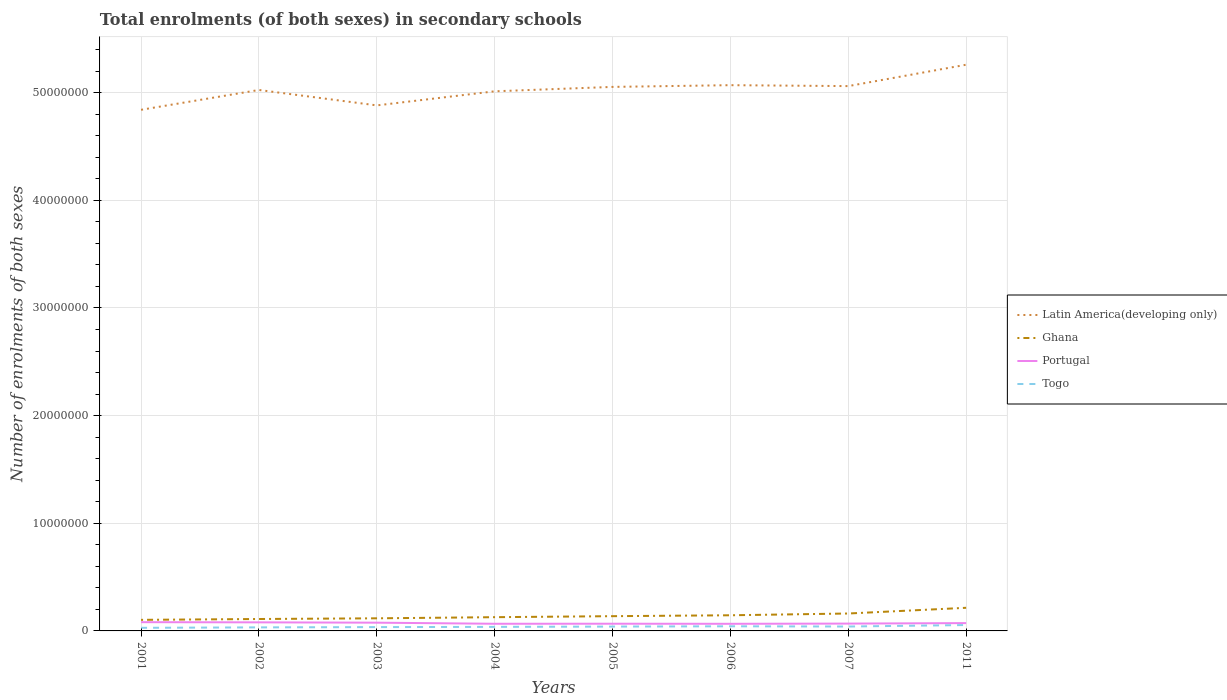How many different coloured lines are there?
Offer a terse response. 4. Across all years, what is the maximum number of enrolments in secondary schools in Latin America(developing only)?
Your answer should be compact. 4.84e+07. In which year was the number of enrolments in secondary schools in Togo maximum?
Your answer should be compact. 2001. What is the total number of enrolments in secondary schools in Portugal in the graph?
Provide a short and direct response. 3.09e+04. What is the difference between the highest and the second highest number of enrolments in secondary schools in Ghana?
Keep it short and to the point. 1.12e+06. Is the number of enrolments in secondary schools in Portugal strictly greater than the number of enrolments in secondary schools in Ghana over the years?
Provide a short and direct response. Yes. How many lines are there?
Offer a terse response. 4. How many years are there in the graph?
Ensure brevity in your answer.  8. Are the values on the major ticks of Y-axis written in scientific E-notation?
Offer a very short reply. No. Does the graph contain any zero values?
Provide a succinct answer. No. How are the legend labels stacked?
Ensure brevity in your answer.  Vertical. What is the title of the graph?
Make the answer very short. Total enrolments (of both sexes) in secondary schools. What is the label or title of the X-axis?
Offer a terse response. Years. What is the label or title of the Y-axis?
Provide a succinct answer. Number of enrolments of both sexes. What is the Number of enrolments of both sexes in Latin America(developing only) in 2001?
Provide a short and direct response. 4.84e+07. What is the Number of enrolments of both sexes in Ghana in 2001?
Provide a short and direct response. 1.03e+06. What is the Number of enrolments of both sexes of Portugal in 2001?
Your answer should be very brief. 8.13e+05. What is the Number of enrolments of both sexes of Togo in 2001?
Offer a very short reply. 2.88e+05. What is the Number of enrolments of both sexes of Latin America(developing only) in 2002?
Ensure brevity in your answer.  5.03e+07. What is the Number of enrolments of both sexes of Ghana in 2002?
Provide a succinct answer. 1.11e+06. What is the Number of enrolments of both sexes of Portugal in 2002?
Give a very brief answer. 7.97e+05. What is the Number of enrolments of both sexes in Togo in 2002?
Make the answer very short. 3.29e+05. What is the Number of enrolments of both sexes of Latin America(developing only) in 2003?
Offer a terse response. 4.88e+07. What is the Number of enrolments of both sexes of Ghana in 2003?
Make the answer very short. 1.17e+06. What is the Number of enrolments of both sexes of Portugal in 2003?
Keep it short and to the point. 7.66e+05. What is the Number of enrolments of both sexes in Togo in 2003?
Provide a short and direct response. 3.55e+05. What is the Number of enrolments of both sexes in Latin America(developing only) in 2004?
Keep it short and to the point. 5.01e+07. What is the Number of enrolments of both sexes of Ghana in 2004?
Keep it short and to the point. 1.28e+06. What is the Number of enrolments of both sexes in Portugal in 2004?
Your answer should be very brief. 6.65e+05. What is the Number of enrolments of both sexes of Togo in 2004?
Provide a short and direct response. 3.75e+05. What is the Number of enrolments of both sexes in Latin America(developing only) in 2005?
Your answer should be compact. 5.05e+07. What is the Number of enrolments of both sexes of Ghana in 2005?
Provide a short and direct response. 1.37e+06. What is the Number of enrolments of both sexes of Portugal in 2005?
Your answer should be very brief. 6.70e+05. What is the Number of enrolments of both sexes in Togo in 2005?
Ensure brevity in your answer.  4.04e+05. What is the Number of enrolments of both sexes in Latin America(developing only) in 2006?
Keep it short and to the point. 5.07e+07. What is the Number of enrolments of both sexes in Ghana in 2006?
Make the answer very short. 1.45e+06. What is the Number of enrolments of both sexes in Portugal in 2006?
Give a very brief answer. 6.62e+05. What is the Number of enrolments of both sexes in Togo in 2006?
Keep it short and to the point. 4.30e+05. What is the Number of enrolments of both sexes of Latin America(developing only) in 2007?
Your answer should be very brief. 5.06e+07. What is the Number of enrolments of both sexes in Ghana in 2007?
Make the answer very short. 1.62e+06. What is the Number of enrolments of both sexes of Portugal in 2007?
Provide a short and direct response. 6.80e+05. What is the Number of enrolments of both sexes in Togo in 2007?
Your response must be concise. 4.09e+05. What is the Number of enrolments of both sexes of Latin America(developing only) in 2011?
Keep it short and to the point. 5.26e+07. What is the Number of enrolments of both sexes in Ghana in 2011?
Make the answer very short. 2.15e+06. What is the Number of enrolments of both sexes of Portugal in 2011?
Keep it short and to the point. 7.26e+05. What is the Number of enrolments of both sexes of Togo in 2011?
Ensure brevity in your answer.  5.46e+05. Across all years, what is the maximum Number of enrolments of both sexes of Latin America(developing only)?
Your answer should be compact. 5.26e+07. Across all years, what is the maximum Number of enrolments of both sexes of Ghana?
Provide a succinct answer. 2.15e+06. Across all years, what is the maximum Number of enrolments of both sexes of Portugal?
Make the answer very short. 8.13e+05. Across all years, what is the maximum Number of enrolments of both sexes of Togo?
Provide a short and direct response. 5.46e+05. Across all years, what is the minimum Number of enrolments of both sexes in Latin America(developing only)?
Make the answer very short. 4.84e+07. Across all years, what is the minimum Number of enrolments of both sexes in Ghana?
Give a very brief answer. 1.03e+06. Across all years, what is the minimum Number of enrolments of both sexes of Portugal?
Give a very brief answer. 6.62e+05. Across all years, what is the minimum Number of enrolments of both sexes of Togo?
Your answer should be compact. 2.88e+05. What is the total Number of enrolments of both sexes in Latin America(developing only) in the graph?
Provide a short and direct response. 4.02e+08. What is the total Number of enrolments of both sexes of Ghana in the graph?
Your answer should be very brief. 1.12e+07. What is the total Number of enrolments of both sexes of Portugal in the graph?
Keep it short and to the point. 5.78e+06. What is the total Number of enrolments of both sexes of Togo in the graph?
Make the answer very short. 3.14e+06. What is the difference between the Number of enrolments of both sexes in Latin America(developing only) in 2001 and that in 2002?
Give a very brief answer. -1.84e+06. What is the difference between the Number of enrolments of both sexes of Ghana in 2001 and that in 2002?
Provide a succinct answer. -7.80e+04. What is the difference between the Number of enrolments of both sexes of Portugal in 2001 and that in 2002?
Provide a succinct answer. 1.61e+04. What is the difference between the Number of enrolments of both sexes of Togo in 2001 and that in 2002?
Provide a short and direct response. -4.10e+04. What is the difference between the Number of enrolments of both sexes of Latin America(developing only) in 2001 and that in 2003?
Your answer should be very brief. -4.09e+05. What is the difference between the Number of enrolments of both sexes in Ghana in 2001 and that in 2003?
Provide a succinct answer. -1.42e+05. What is the difference between the Number of enrolments of both sexes in Portugal in 2001 and that in 2003?
Your answer should be compact. 4.70e+04. What is the difference between the Number of enrolments of both sexes in Togo in 2001 and that in 2003?
Your answer should be compact. -6.66e+04. What is the difference between the Number of enrolments of both sexes in Latin America(developing only) in 2001 and that in 2004?
Offer a very short reply. -1.72e+06. What is the difference between the Number of enrolments of both sexes in Ghana in 2001 and that in 2004?
Your response must be concise. -2.47e+05. What is the difference between the Number of enrolments of both sexes in Portugal in 2001 and that in 2004?
Give a very brief answer. 1.48e+05. What is the difference between the Number of enrolments of both sexes of Togo in 2001 and that in 2004?
Make the answer very short. -8.70e+04. What is the difference between the Number of enrolments of both sexes in Latin America(developing only) in 2001 and that in 2005?
Ensure brevity in your answer.  -2.13e+06. What is the difference between the Number of enrolments of both sexes of Ghana in 2001 and that in 2005?
Give a very brief answer. -3.41e+05. What is the difference between the Number of enrolments of both sexes in Portugal in 2001 and that in 2005?
Provide a succinct answer. 1.44e+05. What is the difference between the Number of enrolments of both sexes of Togo in 2001 and that in 2005?
Offer a very short reply. -1.16e+05. What is the difference between the Number of enrolments of both sexes of Latin America(developing only) in 2001 and that in 2006?
Provide a succinct answer. -2.29e+06. What is the difference between the Number of enrolments of both sexes of Ghana in 2001 and that in 2006?
Make the answer very short. -4.25e+05. What is the difference between the Number of enrolments of both sexes of Portugal in 2001 and that in 2006?
Your response must be concise. 1.51e+05. What is the difference between the Number of enrolments of both sexes of Togo in 2001 and that in 2006?
Offer a very short reply. -1.42e+05. What is the difference between the Number of enrolments of both sexes of Latin America(developing only) in 2001 and that in 2007?
Provide a short and direct response. -2.20e+06. What is the difference between the Number of enrolments of both sexes of Ghana in 2001 and that in 2007?
Offer a terse response. -5.89e+05. What is the difference between the Number of enrolments of both sexes of Portugal in 2001 and that in 2007?
Make the answer very short. 1.33e+05. What is the difference between the Number of enrolments of both sexes of Togo in 2001 and that in 2007?
Your answer should be compact. -1.21e+05. What is the difference between the Number of enrolments of both sexes in Latin America(developing only) in 2001 and that in 2011?
Provide a short and direct response. -4.19e+06. What is the difference between the Number of enrolments of both sexes in Ghana in 2001 and that in 2011?
Offer a very short reply. -1.12e+06. What is the difference between the Number of enrolments of both sexes of Portugal in 2001 and that in 2011?
Offer a very short reply. 8.74e+04. What is the difference between the Number of enrolments of both sexes of Togo in 2001 and that in 2011?
Ensure brevity in your answer.  -2.58e+05. What is the difference between the Number of enrolments of both sexes in Latin America(developing only) in 2002 and that in 2003?
Offer a terse response. 1.43e+06. What is the difference between the Number of enrolments of both sexes in Ghana in 2002 and that in 2003?
Give a very brief answer. -6.35e+04. What is the difference between the Number of enrolments of both sexes of Portugal in 2002 and that in 2003?
Your response must be concise. 3.09e+04. What is the difference between the Number of enrolments of both sexes of Togo in 2002 and that in 2003?
Your answer should be very brief. -2.57e+04. What is the difference between the Number of enrolments of both sexes in Latin America(developing only) in 2002 and that in 2004?
Your answer should be very brief. 1.23e+05. What is the difference between the Number of enrolments of both sexes of Ghana in 2002 and that in 2004?
Offer a terse response. -1.69e+05. What is the difference between the Number of enrolments of both sexes of Portugal in 2002 and that in 2004?
Provide a short and direct response. 1.32e+05. What is the difference between the Number of enrolments of both sexes in Togo in 2002 and that in 2004?
Make the answer very short. -4.61e+04. What is the difference between the Number of enrolments of both sexes in Latin America(developing only) in 2002 and that in 2005?
Make the answer very short. -2.86e+05. What is the difference between the Number of enrolments of both sexes in Ghana in 2002 and that in 2005?
Give a very brief answer. -2.63e+05. What is the difference between the Number of enrolments of both sexes in Portugal in 2002 and that in 2005?
Ensure brevity in your answer.  1.28e+05. What is the difference between the Number of enrolments of both sexes in Togo in 2002 and that in 2005?
Your response must be concise. -7.52e+04. What is the difference between the Number of enrolments of both sexes of Latin America(developing only) in 2002 and that in 2006?
Your answer should be very brief. -4.47e+05. What is the difference between the Number of enrolments of both sexes of Ghana in 2002 and that in 2006?
Keep it short and to the point. -3.47e+05. What is the difference between the Number of enrolments of both sexes of Portugal in 2002 and that in 2006?
Provide a succinct answer. 1.35e+05. What is the difference between the Number of enrolments of both sexes of Togo in 2002 and that in 2006?
Offer a terse response. -1.01e+05. What is the difference between the Number of enrolments of both sexes in Latin America(developing only) in 2002 and that in 2007?
Make the answer very short. -3.61e+05. What is the difference between the Number of enrolments of both sexes in Ghana in 2002 and that in 2007?
Make the answer very short. -5.11e+05. What is the difference between the Number of enrolments of both sexes of Portugal in 2002 and that in 2007?
Keep it short and to the point. 1.17e+05. What is the difference between the Number of enrolments of both sexes of Togo in 2002 and that in 2007?
Provide a short and direct response. -7.97e+04. What is the difference between the Number of enrolments of both sexes in Latin America(developing only) in 2002 and that in 2011?
Provide a short and direct response. -2.35e+06. What is the difference between the Number of enrolments of both sexes of Ghana in 2002 and that in 2011?
Make the answer very short. -1.04e+06. What is the difference between the Number of enrolments of both sexes of Portugal in 2002 and that in 2011?
Keep it short and to the point. 7.13e+04. What is the difference between the Number of enrolments of both sexes in Togo in 2002 and that in 2011?
Keep it short and to the point. -2.17e+05. What is the difference between the Number of enrolments of both sexes of Latin America(developing only) in 2003 and that in 2004?
Provide a short and direct response. -1.31e+06. What is the difference between the Number of enrolments of both sexes in Ghana in 2003 and that in 2004?
Make the answer very short. -1.06e+05. What is the difference between the Number of enrolments of both sexes in Portugal in 2003 and that in 2004?
Your response must be concise. 1.01e+05. What is the difference between the Number of enrolments of both sexes in Togo in 2003 and that in 2004?
Make the answer very short. -2.04e+04. What is the difference between the Number of enrolments of both sexes of Latin America(developing only) in 2003 and that in 2005?
Your answer should be very brief. -1.72e+06. What is the difference between the Number of enrolments of both sexes of Ghana in 2003 and that in 2005?
Your response must be concise. -1.99e+05. What is the difference between the Number of enrolments of both sexes in Portugal in 2003 and that in 2005?
Make the answer very short. 9.66e+04. What is the difference between the Number of enrolments of both sexes of Togo in 2003 and that in 2005?
Provide a short and direct response. -4.95e+04. What is the difference between the Number of enrolments of both sexes of Latin America(developing only) in 2003 and that in 2006?
Give a very brief answer. -1.88e+06. What is the difference between the Number of enrolments of both sexes of Ghana in 2003 and that in 2006?
Make the answer very short. -2.83e+05. What is the difference between the Number of enrolments of both sexes of Portugal in 2003 and that in 2006?
Make the answer very short. 1.04e+05. What is the difference between the Number of enrolments of both sexes in Togo in 2003 and that in 2006?
Provide a short and direct response. -7.51e+04. What is the difference between the Number of enrolments of both sexes in Latin America(developing only) in 2003 and that in 2007?
Give a very brief answer. -1.79e+06. What is the difference between the Number of enrolments of both sexes of Ghana in 2003 and that in 2007?
Give a very brief answer. -4.47e+05. What is the difference between the Number of enrolments of both sexes in Portugal in 2003 and that in 2007?
Give a very brief answer. 8.58e+04. What is the difference between the Number of enrolments of both sexes of Togo in 2003 and that in 2007?
Offer a terse response. -5.40e+04. What is the difference between the Number of enrolments of both sexes of Latin America(developing only) in 2003 and that in 2011?
Provide a short and direct response. -3.78e+06. What is the difference between the Number of enrolments of both sexes in Ghana in 2003 and that in 2011?
Your response must be concise. -9.78e+05. What is the difference between the Number of enrolments of both sexes of Portugal in 2003 and that in 2011?
Make the answer very short. 4.04e+04. What is the difference between the Number of enrolments of both sexes of Togo in 2003 and that in 2011?
Give a very brief answer. -1.91e+05. What is the difference between the Number of enrolments of both sexes of Latin America(developing only) in 2004 and that in 2005?
Make the answer very short. -4.09e+05. What is the difference between the Number of enrolments of both sexes of Ghana in 2004 and that in 2005?
Ensure brevity in your answer.  -9.36e+04. What is the difference between the Number of enrolments of both sexes of Portugal in 2004 and that in 2005?
Provide a succinct answer. -4316. What is the difference between the Number of enrolments of both sexes of Togo in 2004 and that in 2005?
Make the answer very short. -2.91e+04. What is the difference between the Number of enrolments of both sexes in Latin America(developing only) in 2004 and that in 2006?
Your answer should be very brief. -5.70e+05. What is the difference between the Number of enrolments of both sexes of Ghana in 2004 and that in 2006?
Your answer should be very brief. -1.77e+05. What is the difference between the Number of enrolments of both sexes in Portugal in 2004 and that in 2006?
Your response must be concise. 3465. What is the difference between the Number of enrolments of both sexes of Togo in 2004 and that in 2006?
Your answer should be very brief. -5.47e+04. What is the difference between the Number of enrolments of both sexes in Latin America(developing only) in 2004 and that in 2007?
Provide a succinct answer. -4.84e+05. What is the difference between the Number of enrolments of both sexes of Ghana in 2004 and that in 2007?
Provide a short and direct response. -3.41e+05. What is the difference between the Number of enrolments of both sexes in Portugal in 2004 and that in 2007?
Give a very brief answer. -1.51e+04. What is the difference between the Number of enrolments of both sexes in Togo in 2004 and that in 2007?
Give a very brief answer. -3.36e+04. What is the difference between the Number of enrolments of both sexes of Latin America(developing only) in 2004 and that in 2011?
Give a very brief answer. -2.47e+06. What is the difference between the Number of enrolments of both sexes of Ghana in 2004 and that in 2011?
Give a very brief answer. -8.72e+05. What is the difference between the Number of enrolments of both sexes in Portugal in 2004 and that in 2011?
Keep it short and to the point. -6.06e+04. What is the difference between the Number of enrolments of both sexes of Togo in 2004 and that in 2011?
Provide a short and direct response. -1.70e+05. What is the difference between the Number of enrolments of both sexes in Latin America(developing only) in 2005 and that in 2006?
Keep it short and to the point. -1.60e+05. What is the difference between the Number of enrolments of both sexes in Ghana in 2005 and that in 2006?
Keep it short and to the point. -8.38e+04. What is the difference between the Number of enrolments of both sexes in Portugal in 2005 and that in 2006?
Offer a very short reply. 7781. What is the difference between the Number of enrolments of both sexes in Togo in 2005 and that in 2006?
Make the answer very short. -2.56e+04. What is the difference between the Number of enrolments of both sexes of Latin America(developing only) in 2005 and that in 2007?
Your response must be concise. -7.43e+04. What is the difference between the Number of enrolments of both sexes of Ghana in 2005 and that in 2007?
Provide a short and direct response. -2.48e+05. What is the difference between the Number of enrolments of both sexes of Portugal in 2005 and that in 2007?
Provide a short and direct response. -1.08e+04. What is the difference between the Number of enrolments of both sexes in Togo in 2005 and that in 2007?
Keep it short and to the point. -4494. What is the difference between the Number of enrolments of both sexes of Latin America(developing only) in 2005 and that in 2011?
Keep it short and to the point. -2.06e+06. What is the difference between the Number of enrolments of both sexes of Ghana in 2005 and that in 2011?
Ensure brevity in your answer.  -7.78e+05. What is the difference between the Number of enrolments of both sexes of Portugal in 2005 and that in 2011?
Your response must be concise. -5.63e+04. What is the difference between the Number of enrolments of both sexes of Togo in 2005 and that in 2011?
Keep it short and to the point. -1.41e+05. What is the difference between the Number of enrolments of both sexes in Latin America(developing only) in 2006 and that in 2007?
Provide a succinct answer. 8.60e+04. What is the difference between the Number of enrolments of both sexes in Ghana in 2006 and that in 2007?
Offer a terse response. -1.64e+05. What is the difference between the Number of enrolments of both sexes of Portugal in 2006 and that in 2007?
Give a very brief answer. -1.86e+04. What is the difference between the Number of enrolments of both sexes of Togo in 2006 and that in 2007?
Your answer should be compact. 2.11e+04. What is the difference between the Number of enrolments of both sexes of Latin America(developing only) in 2006 and that in 2011?
Offer a very short reply. -1.90e+06. What is the difference between the Number of enrolments of both sexes in Ghana in 2006 and that in 2011?
Keep it short and to the point. -6.94e+05. What is the difference between the Number of enrolments of both sexes in Portugal in 2006 and that in 2011?
Your answer should be very brief. -6.41e+04. What is the difference between the Number of enrolments of both sexes of Togo in 2006 and that in 2011?
Keep it short and to the point. -1.16e+05. What is the difference between the Number of enrolments of both sexes in Latin America(developing only) in 2007 and that in 2011?
Ensure brevity in your answer.  -1.99e+06. What is the difference between the Number of enrolments of both sexes in Ghana in 2007 and that in 2011?
Your answer should be very brief. -5.30e+05. What is the difference between the Number of enrolments of both sexes of Portugal in 2007 and that in 2011?
Offer a very short reply. -4.55e+04. What is the difference between the Number of enrolments of both sexes of Togo in 2007 and that in 2011?
Provide a succinct answer. -1.37e+05. What is the difference between the Number of enrolments of both sexes of Latin America(developing only) in 2001 and the Number of enrolments of both sexes of Ghana in 2002?
Your response must be concise. 4.73e+07. What is the difference between the Number of enrolments of both sexes in Latin America(developing only) in 2001 and the Number of enrolments of both sexes in Portugal in 2002?
Ensure brevity in your answer.  4.76e+07. What is the difference between the Number of enrolments of both sexes in Latin America(developing only) in 2001 and the Number of enrolments of both sexes in Togo in 2002?
Offer a very short reply. 4.81e+07. What is the difference between the Number of enrolments of both sexes of Ghana in 2001 and the Number of enrolments of both sexes of Portugal in 2002?
Keep it short and to the point. 2.32e+05. What is the difference between the Number of enrolments of both sexes in Ghana in 2001 and the Number of enrolments of both sexes in Togo in 2002?
Your answer should be compact. 7.00e+05. What is the difference between the Number of enrolments of both sexes of Portugal in 2001 and the Number of enrolments of both sexes of Togo in 2002?
Provide a short and direct response. 4.84e+05. What is the difference between the Number of enrolments of both sexes in Latin America(developing only) in 2001 and the Number of enrolments of both sexes in Ghana in 2003?
Offer a terse response. 4.72e+07. What is the difference between the Number of enrolments of both sexes of Latin America(developing only) in 2001 and the Number of enrolments of both sexes of Portugal in 2003?
Make the answer very short. 4.76e+07. What is the difference between the Number of enrolments of both sexes of Latin America(developing only) in 2001 and the Number of enrolments of both sexes of Togo in 2003?
Offer a terse response. 4.81e+07. What is the difference between the Number of enrolments of both sexes of Ghana in 2001 and the Number of enrolments of both sexes of Portugal in 2003?
Provide a succinct answer. 2.63e+05. What is the difference between the Number of enrolments of both sexes in Ghana in 2001 and the Number of enrolments of both sexes in Togo in 2003?
Provide a short and direct response. 6.74e+05. What is the difference between the Number of enrolments of both sexes in Portugal in 2001 and the Number of enrolments of both sexes in Togo in 2003?
Your response must be concise. 4.58e+05. What is the difference between the Number of enrolments of both sexes in Latin America(developing only) in 2001 and the Number of enrolments of both sexes in Ghana in 2004?
Keep it short and to the point. 4.71e+07. What is the difference between the Number of enrolments of both sexes of Latin America(developing only) in 2001 and the Number of enrolments of both sexes of Portugal in 2004?
Your answer should be very brief. 4.77e+07. What is the difference between the Number of enrolments of both sexes in Latin America(developing only) in 2001 and the Number of enrolments of both sexes in Togo in 2004?
Give a very brief answer. 4.80e+07. What is the difference between the Number of enrolments of both sexes of Ghana in 2001 and the Number of enrolments of both sexes of Portugal in 2004?
Provide a succinct answer. 3.64e+05. What is the difference between the Number of enrolments of both sexes of Ghana in 2001 and the Number of enrolments of both sexes of Togo in 2004?
Ensure brevity in your answer.  6.54e+05. What is the difference between the Number of enrolments of both sexes of Portugal in 2001 and the Number of enrolments of both sexes of Togo in 2004?
Your response must be concise. 4.38e+05. What is the difference between the Number of enrolments of both sexes of Latin America(developing only) in 2001 and the Number of enrolments of both sexes of Ghana in 2005?
Ensure brevity in your answer.  4.70e+07. What is the difference between the Number of enrolments of both sexes in Latin America(developing only) in 2001 and the Number of enrolments of both sexes in Portugal in 2005?
Offer a terse response. 4.77e+07. What is the difference between the Number of enrolments of both sexes of Latin America(developing only) in 2001 and the Number of enrolments of both sexes of Togo in 2005?
Offer a terse response. 4.80e+07. What is the difference between the Number of enrolments of both sexes of Ghana in 2001 and the Number of enrolments of both sexes of Portugal in 2005?
Make the answer very short. 3.60e+05. What is the difference between the Number of enrolments of both sexes of Ghana in 2001 and the Number of enrolments of both sexes of Togo in 2005?
Your response must be concise. 6.25e+05. What is the difference between the Number of enrolments of both sexes of Portugal in 2001 and the Number of enrolments of both sexes of Togo in 2005?
Make the answer very short. 4.09e+05. What is the difference between the Number of enrolments of both sexes in Latin America(developing only) in 2001 and the Number of enrolments of both sexes in Ghana in 2006?
Keep it short and to the point. 4.70e+07. What is the difference between the Number of enrolments of both sexes of Latin America(developing only) in 2001 and the Number of enrolments of both sexes of Portugal in 2006?
Give a very brief answer. 4.77e+07. What is the difference between the Number of enrolments of both sexes of Latin America(developing only) in 2001 and the Number of enrolments of both sexes of Togo in 2006?
Give a very brief answer. 4.80e+07. What is the difference between the Number of enrolments of both sexes in Ghana in 2001 and the Number of enrolments of both sexes in Portugal in 2006?
Offer a very short reply. 3.68e+05. What is the difference between the Number of enrolments of both sexes in Ghana in 2001 and the Number of enrolments of both sexes in Togo in 2006?
Your response must be concise. 5.99e+05. What is the difference between the Number of enrolments of both sexes of Portugal in 2001 and the Number of enrolments of both sexes of Togo in 2006?
Give a very brief answer. 3.83e+05. What is the difference between the Number of enrolments of both sexes in Latin America(developing only) in 2001 and the Number of enrolments of both sexes in Ghana in 2007?
Your answer should be compact. 4.68e+07. What is the difference between the Number of enrolments of both sexes in Latin America(developing only) in 2001 and the Number of enrolments of both sexes in Portugal in 2007?
Provide a succinct answer. 4.77e+07. What is the difference between the Number of enrolments of both sexes in Latin America(developing only) in 2001 and the Number of enrolments of both sexes in Togo in 2007?
Your answer should be compact. 4.80e+07. What is the difference between the Number of enrolments of both sexes in Ghana in 2001 and the Number of enrolments of both sexes in Portugal in 2007?
Keep it short and to the point. 3.49e+05. What is the difference between the Number of enrolments of both sexes in Ghana in 2001 and the Number of enrolments of both sexes in Togo in 2007?
Keep it short and to the point. 6.20e+05. What is the difference between the Number of enrolments of both sexes of Portugal in 2001 and the Number of enrolments of both sexes of Togo in 2007?
Provide a short and direct response. 4.04e+05. What is the difference between the Number of enrolments of both sexes in Latin America(developing only) in 2001 and the Number of enrolments of both sexes in Ghana in 2011?
Your answer should be compact. 4.63e+07. What is the difference between the Number of enrolments of both sexes in Latin America(developing only) in 2001 and the Number of enrolments of both sexes in Portugal in 2011?
Make the answer very short. 4.77e+07. What is the difference between the Number of enrolments of both sexes in Latin America(developing only) in 2001 and the Number of enrolments of both sexes in Togo in 2011?
Keep it short and to the point. 4.79e+07. What is the difference between the Number of enrolments of both sexes in Ghana in 2001 and the Number of enrolments of both sexes in Portugal in 2011?
Offer a very short reply. 3.03e+05. What is the difference between the Number of enrolments of both sexes of Ghana in 2001 and the Number of enrolments of both sexes of Togo in 2011?
Ensure brevity in your answer.  4.83e+05. What is the difference between the Number of enrolments of both sexes of Portugal in 2001 and the Number of enrolments of both sexes of Togo in 2011?
Keep it short and to the point. 2.67e+05. What is the difference between the Number of enrolments of both sexes of Latin America(developing only) in 2002 and the Number of enrolments of both sexes of Ghana in 2003?
Provide a succinct answer. 4.91e+07. What is the difference between the Number of enrolments of both sexes in Latin America(developing only) in 2002 and the Number of enrolments of both sexes in Portugal in 2003?
Your response must be concise. 4.95e+07. What is the difference between the Number of enrolments of both sexes in Latin America(developing only) in 2002 and the Number of enrolments of both sexes in Togo in 2003?
Your response must be concise. 4.99e+07. What is the difference between the Number of enrolments of both sexes of Ghana in 2002 and the Number of enrolments of both sexes of Portugal in 2003?
Ensure brevity in your answer.  3.41e+05. What is the difference between the Number of enrolments of both sexes in Ghana in 2002 and the Number of enrolments of both sexes in Togo in 2003?
Give a very brief answer. 7.52e+05. What is the difference between the Number of enrolments of both sexes of Portugal in 2002 and the Number of enrolments of both sexes of Togo in 2003?
Offer a very short reply. 4.42e+05. What is the difference between the Number of enrolments of both sexes in Latin America(developing only) in 2002 and the Number of enrolments of both sexes in Ghana in 2004?
Keep it short and to the point. 4.90e+07. What is the difference between the Number of enrolments of both sexes of Latin America(developing only) in 2002 and the Number of enrolments of both sexes of Portugal in 2004?
Your answer should be compact. 4.96e+07. What is the difference between the Number of enrolments of both sexes in Latin America(developing only) in 2002 and the Number of enrolments of both sexes in Togo in 2004?
Give a very brief answer. 4.99e+07. What is the difference between the Number of enrolments of both sexes in Ghana in 2002 and the Number of enrolments of both sexes in Portugal in 2004?
Provide a short and direct response. 4.42e+05. What is the difference between the Number of enrolments of both sexes of Ghana in 2002 and the Number of enrolments of both sexes of Togo in 2004?
Keep it short and to the point. 7.32e+05. What is the difference between the Number of enrolments of both sexes in Portugal in 2002 and the Number of enrolments of both sexes in Togo in 2004?
Ensure brevity in your answer.  4.22e+05. What is the difference between the Number of enrolments of both sexes of Latin America(developing only) in 2002 and the Number of enrolments of both sexes of Ghana in 2005?
Provide a short and direct response. 4.89e+07. What is the difference between the Number of enrolments of both sexes of Latin America(developing only) in 2002 and the Number of enrolments of both sexes of Portugal in 2005?
Your answer should be very brief. 4.96e+07. What is the difference between the Number of enrolments of both sexes in Latin America(developing only) in 2002 and the Number of enrolments of both sexes in Togo in 2005?
Provide a succinct answer. 4.98e+07. What is the difference between the Number of enrolments of both sexes of Ghana in 2002 and the Number of enrolments of both sexes of Portugal in 2005?
Make the answer very short. 4.38e+05. What is the difference between the Number of enrolments of both sexes in Ghana in 2002 and the Number of enrolments of both sexes in Togo in 2005?
Your answer should be very brief. 7.03e+05. What is the difference between the Number of enrolments of both sexes in Portugal in 2002 and the Number of enrolments of both sexes in Togo in 2005?
Provide a succinct answer. 3.93e+05. What is the difference between the Number of enrolments of both sexes in Latin America(developing only) in 2002 and the Number of enrolments of both sexes in Ghana in 2006?
Offer a terse response. 4.88e+07. What is the difference between the Number of enrolments of both sexes of Latin America(developing only) in 2002 and the Number of enrolments of both sexes of Portugal in 2006?
Offer a terse response. 4.96e+07. What is the difference between the Number of enrolments of both sexes in Latin America(developing only) in 2002 and the Number of enrolments of both sexes in Togo in 2006?
Make the answer very short. 4.98e+07. What is the difference between the Number of enrolments of both sexes in Ghana in 2002 and the Number of enrolments of both sexes in Portugal in 2006?
Offer a terse response. 4.45e+05. What is the difference between the Number of enrolments of both sexes in Ghana in 2002 and the Number of enrolments of both sexes in Togo in 2006?
Make the answer very short. 6.77e+05. What is the difference between the Number of enrolments of both sexes in Portugal in 2002 and the Number of enrolments of both sexes in Togo in 2006?
Your answer should be very brief. 3.67e+05. What is the difference between the Number of enrolments of both sexes of Latin America(developing only) in 2002 and the Number of enrolments of both sexes of Ghana in 2007?
Your answer should be very brief. 4.86e+07. What is the difference between the Number of enrolments of both sexes in Latin America(developing only) in 2002 and the Number of enrolments of both sexes in Portugal in 2007?
Your response must be concise. 4.96e+07. What is the difference between the Number of enrolments of both sexes in Latin America(developing only) in 2002 and the Number of enrolments of both sexes in Togo in 2007?
Offer a very short reply. 4.98e+07. What is the difference between the Number of enrolments of both sexes of Ghana in 2002 and the Number of enrolments of both sexes of Portugal in 2007?
Offer a very short reply. 4.27e+05. What is the difference between the Number of enrolments of both sexes of Ghana in 2002 and the Number of enrolments of both sexes of Togo in 2007?
Provide a short and direct response. 6.98e+05. What is the difference between the Number of enrolments of both sexes of Portugal in 2002 and the Number of enrolments of both sexes of Togo in 2007?
Give a very brief answer. 3.88e+05. What is the difference between the Number of enrolments of both sexes of Latin America(developing only) in 2002 and the Number of enrolments of both sexes of Ghana in 2011?
Provide a succinct answer. 4.81e+07. What is the difference between the Number of enrolments of both sexes in Latin America(developing only) in 2002 and the Number of enrolments of both sexes in Portugal in 2011?
Provide a succinct answer. 4.95e+07. What is the difference between the Number of enrolments of both sexes in Latin America(developing only) in 2002 and the Number of enrolments of both sexes in Togo in 2011?
Provide a succinct answer. 4.97e+07. What is the difference between the Number of enrolments of both sexes of Ghana in 2002 and the Number of enrolments of both sexes of Portugal in 2011?
Give a very brief answer. 3.81e+05. What is the difference between the Number of enrolments of both sexes in Ghana in 2002 and the Number of enrolments of both sexes in Togo in 2011?
Offer a very short reply. 5.61e+05. What is the difference between the Number of enrolments of both sexes of Portugal in 2002 and the Number of enrolments of both sexes of Togo in 2011?
Give a very brief answer. 2.51e+05. What is the difference between the Number of enrolments of both sexes in Latin America(developing only) in 2003 and the Number of enrolments of both sexes in Ghana in 2004?
Offer a very short reply. 4.75e+07. What is the difference between the Number of enrolments of both sexes in Latin America(developing only) in 2003 and the Number of enrolments of both sexes in Portugal in 2004?
Provide a succinct answer. 4.82e+07. What is the difference between the Number of enrolments of both sexes in Latin America(developing only) in 2003 and the Number of enrolments of both sexes in Togo in 2004?
Your answer should be very brief. 4.84e+07. What is the difference between the Number of enrolments of both sexes of Ghana in 2003 and the Number of enrolments of both sexes of Portugal in 2004?
Your response must be concise. 5.06e+05. What is the difference between the Number of enrolments of both sexes of Ghana in 2003 and the Number of enrolments of both sexes of Togo in 2004?
Keep it short and to the point. 7.95e+05. What is the difference between the Number of enrolments of both sexes of Portugal in 2003 and the Number of enrolments of both sexes of Togo in 2004?
Your answer should be compact. 3.91e+05. What is the difference between the Number of enrolments of both sexes in Latin America(developing only) in 2003 and the Number of enrolments of both sexes in Ghana in 2005?
Offer a very short reply. 4.74e+07. What is the difference between the Number of enrolments of both sexes of Latin America(developing only) in 2003 and the Number of enrolments of both sexes of Portugal in 2005?
Give a very brief answer. 4.81e+07. What is the difference between the Number of enrolments of both sexes of Latin America(developing only) in 2003 and the Number of enrolments of both sexes of Togo in 2005?
Your response must be concise. 4.84e+07. What is the difference between the Number of enrolments of both sexes in Ghana in 2003 and the Number of enrolments of both sexes in Portugal in 2005?
Offer a very short reply. 5.01e+05. What is the difference between the Number of enrolments of both sexes in Ghana in 2003 and the Number of enrolments of both sexes in Togo in 2005?
Offer a very short reply. 7.66e+05. What is the difference between the Number of enrolments of both sexes of Portugal in 2003 and the Number of enrolments of both sexes of Togo in 2005?
Keep it short and to the point. 3.62e+05. What is the difference between the Number of enrolments of both sexes of Latin America(developing only) in 2003 and the Number of enrolments of both sexes of Ghana in 2006?
Ensure brevity in your answer.  4.74e+07. What is the difference between the Number of enrolments of both sexes in Latin America(developing only) in 2003 and the Number of enrolments of both sexes in Portugal in 2006?
Offer a very short reply. 4.82e+07. What is the difference between the Number of enrolments of both sexes of Latin America(developing only) in 2003 and the Number of enrolments of both sexes of Togo in 2006?
Your answer should be compact. 4.84e+07. What is the difference between the Number of enrolments of both sexes in Ghana in 2003 and the Number of enrolments of both sexes in Portugal in 2006?
Your response must be concise. 5.09e+05. What is the difference between the Number of enrolments of both sexes of Ghana in 2003 and the Number of enrolments of both sexes of Togo in 2006?
Provide a succinct answer. 7.41e+05. What is the difference between the Number of enrolments of both sexes in Portugal in 2003 and the Number of enrolments of both sexes in Togo in 2006?
Provide a succinct answer. 3.36e+05. What is the difference between the Number of enrolments of both sexes of Latin America(developing only) in 2003 and the Number of enrolments of both sexes of Ghana in 2007?
Your answer should be compact. 4.72e+07. What is the difference between the Number of enrolments of both sexes of Latin America(developing only) in 2003 and the Number of enrolments of both sexes of Portugal in 2007?
Give a very brief answer. 4.81e+07. What is the difference between the Number of enrolments of both sexes in Latin America(developing only) in 2003 and the Number of enrolments of both sexes in Togo in 2007?
Provide a short and direct response. 4.84e+07. What is the difference between the Number of enrolments of both sexes in Ghana in 2003 and the Number of enrolments of both sexes in Portugal in 2007?
Ensure brevity in your answer.  4.90e+05. What is the difference between the Number of enrolments of both sexes in Ghana in 2003 and the Number of enrolments of both sexes in Togo in 2007?
Provide a succinct answer. 7.62e+05. What is the difference between the Number of enrolments of both sexes of Portugal in 2003 and the Number of enrolments of both sexes of Togo in 2007?
Ensure brevity in your answer.  3.57e+05. What is the difference between the Number of enrolments of both sexes in Latin America(developing only) in 2003 and the Number of enrolments of both sexes in Ghana in 2011?
Provide a short and direct response. 4.67e+07. What is the difference between the Number of enrolments of both sexes of Latin America(developing only) in 2003 and the Number of enrolments of both sexes of Portugal in 2011?
Ensure brevity in your answer.  4.81e+07. What is the difference between the Number of enrolments of both sexes of Latin America(developing only) in 2003 and the Number of enrolments of both sexes of Togo in 2011?
Your answer should be compact. 4.83e+07. What is the difference between the Number of enrolments of both sexes in Ghana in 2003 and the Number of enrolments of both sexes in Portugal in 2011?
Ensure brevity in your answer.  4.45e+05. What is the difference between the Number of enrolments of both sexes in Ghana in 2003 and the Number of enrolments of both sexes in Togo in 2011?
Your response must be concise. 6.25e+05. What is the difference between the Number of enrolments of both sexes in Portugal in 2003 and the Number of enrolments of both sexes in Togo in 2011?
Offer a terse response. 2.20e+05. What is the difference between the Number of enrolments of both sexes in Latin America(developing only) in 2004 and the Number of enrolments of both sexes in Ghana in 2005?
Keep it short and to the point. 4.88e+07. What is the difference between the Number of enrolments of both sexes in Latin America(developing only) in 2004 and the Number of enrolments of both sexes in Portugal in 2005?
Keep it short and to the point. 4.95e+07. What is the difference between the Number of enrolments of both sexes in Latin America(developing only) in 2004 and the Number of enrolments of both sexes in Togo in 2005?
Provide a short and direct response. 4.97e+07. What is the difference between the Number of enrolments of both sexes of Ghana in 2004 and the Number of enrolments of both sexes of Portugal in 2005?
Your response must be concise. 6.07e+05. What is the difference between the Number of enrolments of both sexes in Ghana in 2004 and the Number of enrolments of both sexes in Togo in 2005?
Provide a short and direct response. 8.72e+05. What is the difference between the Number of enrolments of both sexes in Portugal in 2004 and the Number of enrolments of both sexes in Togo in 2005?
Ensure brevity in your answer.  2.61e+05. What is the difference between the Number of enrolments of both sexes of Latin America(developing only) in 2004 and the Number of enrolments of both sexes of Ghana in 2006?
Keep it short and to the point. 4.87e+07. What is the difference between the Number of enrolments of both sexes of Latin America(developing only) in 2004 and the Number of enrolments of both sexes of Portugal in 2006?
Provide a succinct answer. 4.95e+07. What is the difference between the Number of enrolments of both sexes in Latin America(developing only) in 2004 and the Number of enrolments of both sexes in Togo in 2006?
Keep it short and to the point. 4.97e+07. What is the difference between the Number of enrolments of both sexes of Ghana in 2004 and the Number of enrolments of both sexes of Portugal in 2006?
Your response must be concise. 6.15e+05. What is the difference between the Number of enrolments of both sexes of Ghana in 2004 and the Number of enrolments of both sexes of Togo in 2006?
Provide a short and direct response. 8.47e+05. What is the difference between the Number of enrolments of both sexes of Portugal in 2004 and the Number of enrolments of both sexes of Togo in 2006?
Provide a short and direct response. 2.35e+05. What is the difference between the Number of enrolments of both sexes in Latin America(developing only) in 2004 and the Number of enrolments of both sexes in Ghana in 2007?
Your answer should be very brief. 4.85e+07. What is the difference between the Number of enrolments of both sexes of Latin America(developing only) in 2004 and the Number of enrolments of both sexes of Portugal in 2007?
Your answer should be compact. 4.94e+07. What is the difference between the Number of enrolments of both sexes in Latin America(developing only) in 2004 and the Number of enrolments of both sexes in Togo in 2007?
Keep it short and to the point. 4.97e+07. What is the difference between the Number of enrolments of both sexes of Ghana in 2004 and the Number of enrolments of both sexes of Portugal in 2007?
Offer a terse response. 5.96e+05. What is the difference between the Number of enrolments of both sexes of Ghana in 2004 and the Number of enrolments of both sexes of Togo in 2007?
Offer a terse response. 8.68e+05. What is the difference between the Number of enrolments of both sexes in Portugal in 2004 and the Number of enrolments of both sexes in Togo in 2007?
Your answer should be compact. 2.56e+05. What is the difference between the Number of enrolments of both sexes in Latin America(developing only) in 2004 and the Number of enrolments of both sexes in Ghana in 2011?
Offer a very short reply. 4.80e+07. What is the difference between the Number of enrolments of both sexes of Latin America(developing only) in 2004 and the Number of enrolments of both sexes of Portugal in 2011?
Your answer should be very brief. 4.94e+07. What is the difference between the Number of enrolments of both sexes of Latin America(developing only) in 2004 and the Number of enrolments of both sexes of Togo in 2011?
Ensure brevity in your answer.  4.96e+07. What is the difference between the Number of enrolments of both sexes of Ghana in 2004 and the Number of enrolments of both sexes of Portugal in 2011?
Your response must be concise. 5.51e+05. What is the difference between the Number of enrolments of both sexes in Ghana in 2004 and the Number of enrolments of both sexes in Togo in 2011?
Your response must be concise. 7.31e+05. What is the difference between the Number of enrolments of both sexes of Portugal in 2004 and the Number of enrolments of both sexes of Togo in 2011?
Your answer should be very brief. 1.19e+05. What is the difference between the Number of enrolments of both sexes of Latin America(developing only) in 2005 and the Number of enrolments of both sexes of Ghana in 2006?
Your response must be concise. 4.91e+07. What is the difference between the Number of enrolments of both sexes of Latin America(developing only) in 2005 and the Number of enrolments of both sexes of Portugal in 2006?
Offer a terse response. 4.99e+07. What is the difference between the Number of enrolments of both sexes in Latin America(developing only) in 2005 and the Number of enrolments of both sexes in Togo in 2006?
Make the answer very short. 5.01e+07. What is the difference between the Number of enrolments of both sexes of Ghana in 2005 and the Number of enrolments of both sexes of Portugal in 2006?
Make the answer very short. 7.09e+05. What is the difference between the Number of enrolments of both sexes of Ghana in 2005 and the Number of enrolments of both sexes of Togo in 2006?
Provide a short and direct response. 9.40e+05. What is the difference between the Number of enrolments of both sexes of Portugal in 2005 and the Number of enrolments of both sexes of Togo in 2006?
Your response must be concise. 2.39e+05. What is the difference between the Number of enrolments of both sexes in Latin America(developing only) in 2005 and the Number of enrolments of both sexes in Ghana in 2007?
Keep it short and to the point. 4.89e+07. What is the difference between the Number of enrolments of both sexes in Latin America(developing only) in 2005 and the Number of enrolments of both sexes in Portugal in 2007?
Your answer should be compact. 4.99e+07. What is the difference between the Number of enrolments of both sexes in Latin America(developing only) in 2005 and the Number of enrolments of both sexes in Togo in 2007?
Make the answer very short. 5.01e+07. What is the difference between the Number of enrolments of both sexes in Ghana in 2005 and the Number of enrolments of both sexes in Portugal in 2007?
Provide a short and direct response. 6.90e+05. What is the difference between the Number of enrolments of both sexes in Ghana in 2005 and the Number of enrolments of both sexes in Togo in 2007?
Give a very brief answer. 9.61e+05. What is the difference between the Number of enrolments of both sexes of Portugal in 2005 and the Number of enrolments of both sexes of Togo in 2007?
Ensure brevity in your answer.  2.61e+05. What is the difference between the Number of enrolments of both sexes in Latin America(developing only) in 2005 and the Number of enrolments of both sexes in Ghana in 2011?
Your answer should be very brief. 4.84e+07. What is the difference between the Number of enrolments of both sexes of Latin America(developing only) in 2005 and the Number of enrolments of both sexes of Portugal in 2011?
Offer a very short reply. 4.98e+07. What is the difference between the Number of enrolments of both sexes in Latin America(developing only) in 2005 and the Number of enrolments of both sexes in Togo in 2011?
Offer a terse response. 5.00e+07. What is the difference between the Number of enrolments of both sexes in Ghana in 2005 and the Number of enrolments of both sexes in Portugal in 2011?
Give a very brief answer. 6.44e+05. What is the difference between the Number of enrolments of both sexes in Ghana in 2005 and the Number of enrolments of both sexes in Togo in 2011?
Your answer should be compact. 8.24e+05. What is the difference between the Number of enrolments of both sexes in Portugal in 2005 and the Number of enrolments of both sexes in Togo in 2011?
Offer a very short reply. 1.24e+05. What is the difference between the Number of enrolments of both sexes of Latin America(developing only) in 2006 and the Number of enrolments of both sexes of Ghana in 2007?
Offer a very short reply. 4.91e+07. What is the difference between the Number of enrolments of both sexes in Latin America(developing only) in 2006 and the Number of enrolments of both sexes in Portugal in 2007?
Your answer should be very brief. 5.00e+07. What is the difference between the Number of enrolments of both sexes of Latin America(developing only) in 2006 and the Number of enrolments of both sexes of Togo in 2007?
Make the answer very short. 5.03e+07. What is the difference between the Number of enrolments of both sexes in Ghana in 2006 and the Number of enrolments of both sexes in Portugal in 2007?
Your answer should be very brief. 7.74e+05. What is the difference between the Number of enrolments of both sexes of Ghana in 2006 and the Number of enrolments of both sexes of Togo in 2007?
Make the answer very short. 1.05e+06. What is the difference between the Number of enrolments of both sexes in Portugal in 2006 and the Number of enrolments of both sexes in Togo in 2007?
Offer a terse response. 2.53e+05. What is the difference between the Number of enrolments of both sexes in Latin America(developing only) in 2006 and the Number of enrolments of both sexes in Ghana in 2011?
Offer a terse response. 4.85e+07. What is the difference between the Number of enrolments of both sexes in Latin America(developing only) in 2006 and the Number of enrolments of both sexes in Portugal in 2011?
Your response must be concise. 5.00e+07. What is the difference between the Number of enrolments of both sexes in Latin America(developing only) in 2006 and the Number of enrolments of both sexes in Togo in 2011?
Your answer should be very brief. 5.02e+07. What is the difference between the Number of enrolments of both sexes in Ghana in 2006 and the Number of enrolments of both sexes in Portugal in 2011?
Provide a succinct answer. 7.28e+05. What is the difference between the Number of enrolments of both sexes in Ghana in 2006 and the Number of enrolments of both sexes in Togo in 2011?
Ensure brevity in your answer.  9.08e+05. What is the difference between the Number of enrolments of both sexes of Portugal in 2006 and the Number of enrolments of both sexes of Togo in 2011?
Your answer should be very brief. 1.16e+05. What is the difference between the Number of enrolments of both sexes in Latin America(developing only) in 2007 and the Number of enrolments of both sexes in Ghana in 2011?
Provide a succinct answer. 4.85e+07. What is the difference between the Number of enrolments of both sexes of Latin America(developing only) in 2007 and the Number of enrolments of both sexes of Portugal in 2011?
Offer a terse response. 4.99e+07. What is the difference between the Number of enrolments of both sexes in Latin America(developing only) in 2007 and the Number of enrolments of both sexes in Togo in 2011?
Your response must be concise. 5.01e+07. What is the difference between the Number of enrolments of both sexes of Ghana in 2007 and the Number of enrolments of both sexes of Portugal in 2011?
Your answer should be very brief. 8.92e+05. What is the difference between the Number of enrolments of both sexes in Ghana in 2007 and the Number of enrolments of both sexes in Togo in 2011?
Make the answer very short. 1.07e+06. What is the difference between the Number of enrolments of both sexes in Portugal in 2007 and the Number of enrolments of both sexes in Togo in 2011?
Provide a short and direct response. 1.34e+05. What is the average Number of enrolments of both sexes in Latin America(developing only) per year?
Your answer should be very brief. 5.03e+07. What is the average Number of enrolments of both sexes in Ghana per year?
Provide a short and direct response. 1.40e+06. What is the average Number of enrolments of both sexes of Portugal per year?
Offer a very short reply. 7.22e+05. What is the average Number of enrolments of both sexes in Togo per year?
Give a very brief answer. 3.92e+05. In the year 2001, what is the difference between the Number of enrolments of both sexes in Latin America(developing only) and Number of enrolments of both sexes in Ghana?
Offer a terse response. 4.74e+07. In the year 2001, what is the difference between the Number of enrolments of both sexes in Latin America(developing only) and Number of enrolments of both sexes in Portugal?
Give a very brief answer. 4.76e+07. In the year 2001, what is the difference between the Number of enrolments of both sexes of Latin America(developing only) and Number of enrolments of both sexes of Togo?
Make the answer very short. 4.81e+07. In the year 2001, what is the difference between the Number of enrolments of both sexes of Ghana and Number of enrolments of both sexes of Portugal?
Your response must be concise. 2.16e+05. In the year 2001, what is the difference between the Number of enrolments of both sexes of Ghana and Number of enrolments of both sexes of Togo?
Keep it short and to the point. 7.41e+05. In the year 2001, what is the difference between the Number of enrolments of both sexes in Portugal and Number of enrolments of both sexes in Togo?
Your answer should be very brief. 5.25e+05. In the year 2002, what is the difference between the Number of enrolments of both sexes of Latin America(developing only) and Number of enrolments of both sexes of Ghana?
Your answer should be very brief. 4.91e+07. In the year 2002, what is the difference between the Number of enrolments of both sexes of Latin America(developing only) and Number of enrolments of both sexes of Portugal?
Offer a very short reply. 4.95e+07. In the year 2002, what is the difference between the Number of enrolments of both sexes in Latin America(developing only) and Number of enrolments of both sexes in Togo?
Your answer should be compact. 4.99e+07. In the year 2002, what is the difference between the Number of enrolments of both sexes in Ghana and Number of enrolments of both sexes in Portugal?
Provide a succinct answer. 3.10e+05. In the year 2002, what is the difference between the Number of enrolments of both sexes of Ghana and Number of enrolments of both sexes of Togo?
Your answer should be very brief. 7.78e+05. In the year 2002, what is the difference between the Number of enrolments of both sexes in Portugal and Number of enrolments of both sexes in Togo?
Offer a terse response. 4.68e+05. In the year 2003, what is the difference between the Number of enrolments of both sexes of Latin America(developing only) and Number of enrolments of both sexes of Ghana?
Give a very brief answer. 4.76e+07. In the year 2003, what is the difference between the Number of enrolments of both sexes in Latin America(developing only) and Number of enrolments of both sexes in Portugal?
Your answer should be very brief. 4.81e+07. In the year 2003, what is the difference between the Number of enrolments of both sexes of Latin America(developing only) and Number of enrolments of both sexes of Togo?
Provide a succinct answer. 4.85e+07. In the year 2003, what is the difference between the Number of enrolments of both sexes of Ghana and Number of enrolments of both sexes of Portugal?
Keep it short and to the point. 4.05e+05. In the year 2003, what is the difference between the Number of enrolments of both sexes in Ghana and Number of enrolments of both sexes in Togo?
Your answer should be very brief. 8.16e+05. In the year 2003, what is the difference between the Number of enrolments of both sexes of Portugal and Number of enrolments of both sexes of Togo?
Make the answer very short. 4.11e+05. In the year 2004, what is the difference between the Number of enrolments of both sexes of Latin America(developing only) and Number of enrolments of both sexes of Ghana?
Offer a very short reply. 4.89e+07. In the year 2004, what is the difference between the Number of enrolments of both sexes of Latin America(developing only) and Number of enrolments of both sexes of Portugal?
Ensure brevity in your answer.  4.95e+07. In the year 2004, what is the difference between the Number of enrolments of both sexes of Latin America(developing only) and Number of enrolments of both sexes of Togo?
Your answer should be compact. 4.98e+07. In the year 2004, what is the difference between the Number of enrolments of both sexes of Ghana and Number of enrolments of both sexes of Portugal?
Give a very brief answer. 6.11e+05. In the year 2004, what is the difference between the Number of enrolments of both sexes of Ghana and Number of enrolments of both sexes of Togo?
Make the answer very short. 9.01e+05. In the year 2004, what is the difference between the Number of enrolments of both sexes in Portugal and Number of enrolments of both sexes in Togo?
Provide a short and direct response. 2.90e+05. In the year 2005, what is the difference between the Number of enrolments of both sexes of Latin America(developing only) and Number of enrolments of both sexes of Ghana?
Ensure brevity in your answer.  4.92e+07. In the year 2005, what is the difference between the Number of enrolments of both sexes of Latin America(developing only) and Number of enrolments of both sexes of Portugal?
Your answer should be compact. 4.99e+07. In the year 2005, what is the difference between the Number of enrolments of both sexes of Latin America(developing only) and Number of enrolments of both sexes of Togo?
Your answer should be compact. 5.01e+07. In the year 2005, what is the difference between the Number of enrolments of both sexes in Ghana and Number of enrolments of both sexes in Portugal?
Your answer should be compact. 7.01e+05. In the year 2005, what is the difference between the Number of enrolments of both sexes of Ghana and Number of enrolments of both sexes of Togo?
Offer a terse response. 9.66e+05. In the year 2005, what is the difference between the Number of enrolments of both sexes in Portugal and Number of enrolments of both sexes in Togo?
Your answer should be very brief. 2.65e+05. In the year 2006, what is the difference between the Number of enrolments of both sexes in Latin America(developing only) and Number of enrolments of both sexes in Ghana?
Your answer should be very brief. 4.92e+07. In the year 2006, what is the difference between the Number of enrolments of both sexes in Latin America(developing only) and Number of enrolments of both sexes in Portugal?
Offer a very short reply. 5.00e+07. In the year 2006, what is the difference between the Number of enrolments of both sexes of Latin America(developing only) and Number of enrolments of both sexes of Togo?
Give a very brief answer. 5.03e+07. In the year 2006, what is the difference between the Number of enrolments of both sexes of Ghana and Number of enrolments of both sexes of Portugal?
Provide a short and direct response. 7.92e+05. In the year 2006, what is the difference between the Number of enrolments of both sexes in Ghana and Number of enrolments of both sexes in Togo?
Keep it short and to the point. 1.02e+06. In the year 2006, what is the difference between the Number of enrolments of both sexes of Portugal and Number of enrolments of both sexes of Togo?
Make the answer very short. 2.32e+05. In the year 2007, what is the difference between the Number of enrolments of both sexes in Latin America(developing only) and Number of enrolments of both sexes in Ghana?
Ensure brevity in your answer.  4.90e+07. In the year 2007, what is the difference between the Number of enrolments of both sexes in Latin America(developing only) and Number of enrolments of both sexes in Portugal?
Provide a succinct answer. 4.99e+07. In the year 2007, what is the difference between the Number of enrolments of both sexes of Latin America(developing only) and Number of enrolments of both sexes of Togo?
Make the answer very short. 5.02e+07. In the year 2007, what is the difference between the Number of enrolments of both sexes in Ghana and Number of enrolments of both sexes in Portugal?
Offer a terse response. 9.37e+05. In the year 2007, what is the difference between the Number of enrolments of both sexes of Ghana and Number of enrolments of both sexes of Togo?
Your answer should be very brief. 1.21e+06. In the year 2007, what is the difference between the Number of enrolments of both sexes in Portugal and Number of enrolments of both sexes in Togo?
Give a very brief answer. 2.71e+05. In the year 2011, what is the difference between the Number of enrolments of both sexes of Latin America(developing only) and Number of enrolments of both sexes of Ghana?
Offer a very short reply. 5.04e+07. In the year 2011, what is the difference between the Number of enrolments of both sexes in Latin America(developing only) and Number of enrolments of both sexes in Portugal?
Give a very brief answer. 5.19e+07. In the year 2011, what is the difference between the Number of enrolments of both sexes of Latin America(developing only) and Number of enrolments of both sexes of Togo?
Keep it short and to the point. 5.21e+07. In the year 2011, what is the difference between the Number of enrolments of both sexes in Ghana and Number of enrolments of both sexes in Portugal?
Ensure brevity in your answer.  1.42e+06. In the year 2011, what is the difference between the Number of enrolments of both sexes of Ghana and Number of enrolments of both sexes of Togo?
Offer a very short reply. 1.60e+06. In the year 2011, what is the difference between the Number of enrolments of both sexes in Portugal and Number of enrolments of both sexes in Togo?
Your answer should be very brief. 1.80e+05. What is the ratio of the Number of enrolments of both sexes in Latin America(developing only) in 2001 to that in 2002?
Give a very brief answer. 0.96. What is the ratio of the Number of enrolments of both sexes in Ghana in 2001 to that in 2002?
Offer a very short reply. 0.93. What is the ratio of the Number of enrolments of both sexes in Portugal in 2001 to that in 2002?
Ensure brevity in your answer.  1.02. What is the ratio of the Number of enrolments of both sexes in Togo in 2001 to that in 2002?
Ensure brevity in your answer.  0.88. What is the ratio of the Number of enrolments of both sexes in Ghana in 2001 to that in 2003?
Keep it short and to the point. 0.88. What is the ratio of the Number of enrolments of both sexes of Portugal in 2001 to that in 2003?
Provide a succinct answer. 1.06. What is the ratio of the Number of enrolments of both sexes of Togo in 2001 to that in 2003?
Offer a terse response. 0.81. What is the ratio of the Number of enrolments of both sexes of Latin America(developing only) in 2001 to that in 2004?
Offer a very short reply. 0.97. What is the ratio of the Number of enrolments of both sexes of Ghana in 2001 to that in 2004?
Provide a short and direct response. 0.81. What is the ratio of the Number of enrolments of both sexes of Portugal in 2001 to that in 2004?
Keep it short and to the point. 1.22. What is the ratio of the Number of enrolments of both sexes in Togo in 2001 to that in 2004?
Ensure brevity in your answer.  0.77. What is the ratio of the Number of enrolments of both sexes in Latin America(developing only) in 2001 to that in 2005?
Offer a very short reply. 0.96. What is the ratio of the Number of enrolments of both sexes of Ghana in 2001 to that in 2005?
Make the answer very short. 0.75. What is the ratio of the Number of enrolments of both sexes of Portugal in 2001 to that in 2005?
Offer a very short reply. 1.21. What is the ratio of the Number of enrolments of both sexes in Togo in 2001 to that in 2005?
Provide a succinct answer. 0.71. What is the ratio of the Number of enrolments of both sexes in Latin America(developing only) in 2001 to that in 2006?
Offer a very short reply. 0.95. What is the ratio of the Number of enrolments of both sexes in Ghana in 2001 to that in 2006?
Offer a very short reply. 0.71. What is the ratio of the Number of enrolments of both sexes of Portugal in 2001 to that in 2006?
Provide a succinct answer. 1.23. What is the ratio of the Number of enrolments of both sexes of Togo in 2001 to that in 2006?
Provide a short and direct response. 0.67. What is the ratio of the Number of enrolments of both sexes in Latin America(developing only) in 2001 to that in 2007?
Make the answer very short. 0.96. What is the ratio of the Number of enrolments of both sexes in Ghana in 2001 to that in 2007?
Provide a short and direct response. 0.64. What is the ratio of the Number of enrolments of both sexes of Portugal in 2001 to that in 2007?
Give a very brief answer. 1.2. What is the ratio of the Number of enrolments of both sexes in Togo in 2001 to that in 2007?
Ensure brevity in your answer.  0.71. What is the ratio of the Number of enrolments of both sexes in Latin America(developing only) in 2001 to that in 2011?
Ensure brevity in your answer.  0.92. What is the ratio of the Number of enrolments of both sexes in Ghana in 2001 to that in 2011?
Give a very brief answer. 0.48. What is the ratio of the Number of enrolments of both sexes of Portugal in 2001 to that in 2011?
Your response must be concise. 1.12. What is the ratio of the Number of enrolments of both sexes of Togo in 2001 to that in 2011?
Provide a succinct answer. 0.53. What is the ratio of the Number of enrolments of both sexes of Latin America(developing only) in 2002 to that in 2003?
Your response must be concise. 1.03. What is the ratio of the Number of enrolments of both sexes of Ghana in 2002 to that in 2003?
Your response must be concise. 0.95. What is the ratio of the Number of enrolments of both sexes of Portugal in 2002 to that in 2003?
Your answer should be very brief. 1.04. What is the ratio of the Number of enrolments of both sexes of Togo in 2002 to that in 2003?
Your response must be concise. 0.93. What is the ratio of the Number of enrolments of both sexes in Ghana in 2002 to that in 2004?
Your answer should be very brief. 0.87. What is the ratio of the Number of enrolments of both sexes in Portugal in 2002 to that in 2004?
Offer a terse response. 1.2. What is the ratio of the Number of enrolments of both sexes in Togo in 2002 to that in 2004?
Keep it short and to the point. 0.88. What is the ratio of the Number of enrolments of both sexes in Latin America(developing only) in 2002 to that in 2005?
Offer a very short reply. 0.99. What is the ratio of the Number of enrolments of both sexes of Ghana in 2002 to that in 2005?
Offer a terse response. 0.81. What is the ratio of the Number of enrolments of both sexes in Portugal in 2002 to that in 2005?
Your answer should be compact. 1.19. What is the ratio of the Number of enrolments of both sexes in Togo in 2002 to that in 2005?
Offer a very short reply. 0.81. What is the ratio of the Number of enrolments of both sexes in Ghana in 2002 to that in 2006?
Provide a short and direct response. 0.76. What is the ratio of the Number of enrolments of both sexes in Portugal in 2002 to that in 2006?
Make the answer very short. 1.2. What is the ratio of the Number of enrolments of both sexes of Togo in 2002 to that in 2006?
Provide a succinct answer. 0.77. What is the ratio of the Number of enrolments of both sexes of Ghana in 2002 to that in 2007?
Your answer should be very brief. 0.68. What is the ratio of the Number of enrolments of both sexes of Portugal in 2002 to that in 2007?
Give a very brief answer. 1.17. What is the ratio of the Number of enrolments of both sexes in Togo in 2002 to that in 2007?
Offer a very short reply. 0.81. What is the ratio of the Number of enrolments of both sexes in Latin America(developing only) in 2002 to that in 2011?
Your answer should be very brief. 0.96. What is the ratio of the Number of enrolments of both sexes of Ghana in 2002 to that in 2011?
Make the answer very short. 0.52. What is the ratio of the Number of enrolments of both sexes of Portugal in 2002 to that in 2011?
Your answer should be very brief. 1.1. What is the ratio of the Number of enrolments of both sexes in Togo in 2002 to that in 2011?
Your answer should be very brief. 0.6. What is the ratio of the Number of enrolments of both sexes of Latin America(developing only) in 2003 to that in 2004?
Your answer should be very brief. 0.97. What is the ratio of the Number of enrolments of both sexes of Ghana in 2003 to that in 2004?
Provide a short and direct response. 0.92. What is the ratio of the Number of enrolments of both sexes in Portugal in 2003 to that in 2004?
Keep it short and to the point. 1.15. What is the ratio of the Number of enrolments of both sexes of Togo in 2003 to that in 2004?
Provide a short and direct response. 0.95. What is the ratio of the Number of enrolments of both sexes of Latin America(developing only) in 2003 to that in 2005?
Ensure brevity in your answer.  0.97. What is the ratio of the Number of enrolments of both sexes in Ghana in 2003 to that in 2005?
Offer a very short reply. 0.85. What is the ratio of the Number of enrolments of both sexes of Portugal in 2003 to that in 2005?
Make the answer very short. 1.14. What is the ratio of the Number of enrolments of both sexes in Togo in 2003 to that in 2005?
Offer a terse response. 0.88. What is the ratio of the Number of enrolments of both sexes in Ghana in 2003 to that in 2006?
Provide a succinct answer. 0.81. What is the ratio of the Number of enrolments of both sexes of Portugal in 2003 to that in 2006?
Keep it short and to the point. 1.16. What is the ratio of the Number of enrolments of both sexes in Togo in 2003 to that in 2006?
Keep it short and to the point. 0.83. What is the ratio of the Number of enrolments of both sexes of Latin America(developing only) in 2003 to that in 2007?
Ensure brevity in your answer.  0.96. What is the ratio of the Number of enrolments of both sexes of Ghana in 2003 to that in 2007?
Keep it short and to the point. 0.72. What is the ratio of the Number of enrolments of both sexes of Portugal in 2003 to that in 2007?
Provide a short and direct response. 1.13. What is the ratio of the Number of enrolments of both sexes of Togo in 2003 to that in 2007?
Provide a short and direct response. 0.87. What is the ratio of the Number of enrolments of both sexes of Latin America(developing only) in 2003 to that in 2011?
Your answer should be very brief. 0.93. What is the ratio of the Number of enrolments of both sexes in Ghana in 2003 to that in 2011?
Make the answer very short. 0.55. What is the ratio of the Number of enrolments of both sexes in Portugal in 2003 to that in 2011?
Provide a short and direct response. 1.06. What is the ratio of the Number of enrolments of both sexes of Togo in 2003 to that in 2011?
Offer a very short reply. 0.65. What is the ratio of the Number of enrolments of both sexes in Ghana in 2004 to that in 2005?
Your answer should be compact. 0.93. What is the ratio of the Number of enrolments of both sexes of Togo in 2004 to that in 2005?
Keep it short and to the point. 0.93. What is the ratio of the Number of enrolments of both sexes of Latin America(developing only) in 2004 to that in 2006?
Provide a succinct answer. 0.99. What is the ratio of the Number of enrolments of both sexes of Ghana in 2004 to that in 2006?
Your response must be concise. 0.88. What is the ratio of the Number of enrolments of both sexes of Togo in 2004 to that in 2006?
Your answer should be very brief. 0.87. What is the ratio of the Number of enrolments of both sexes in Ghana in 2004 to that in 2007?
Give a very brief answer. 0.79. What is the ratio of the Number of enrolments of both sexes in Portugal in 2004 to that in 2007?
Make the answer very short. 0.98. What is the ratio of the Number of enrolments of both sexes of Togo in 2004 to that in 2007?
Provide a succinct answer. 0.92. What is the ratio of the Number of enrolments of both sexes in Latin America(developing only) in 2004 to that in 2011?
Provide a short and direct response. 0.95. What is the ratio of the Number of enrolments of both sexes in Ghana in 2004 to that in 2011?
Your answer should be compact. 0.59. What is the ratio of the Number of enrolments of both sexes of Portugal in 2004 to that in 2011?
Ensure brevity in your answer.  0.92. What is the ratio of the Number of enrolments of both sexes of Togo in 2004 to that in 2011?
Ensure brevity in your answer.  0.69. What is the ratio of the Number of enrolments of both sexes of Latin America(developing only) in 2005 to that in 2006?
Keep it short and to the point. 1. What is the ratio of the Number of enrolments of both sexes of Ghana in 2005 to that in 2006?
Keep it short and to the point. 0.94. What is the ratio of the Number of enrolments of both sexes in Portugal in 2005 to that in 2006?
Your answer should be compact. 1.01. What is the ratio of the Number of enrolments of both sexes in Togo in 2005 to that in 2006?
Offer a terse response. 0.94. What is the ratio of the Number of enrolments of both sexes in Latin America(developing only) in 2005 to that in 2007?
Keep it short and to the point. 1. What is the ratio of the Number of enrolments of both sexes in Ghana in 2005 to that in 2007?
Make the answer very short. 0.85. What is the ratio of the Number of enrolments of both sexes in Portugal in 2005 to that in 2007?
Provide a succinct answer. 0.98. What is the ratio of the Number of enrolments of both sexes of Latin America(developing only) in 2005 to that in 2011?
Your answer should be very brief. 0.96. What is the ratio of the Number of enrolments of both sexes in Ghana in 2005 to that in 2011?
Provide a short and direct response. 0.64. What is the ratio of the Number of enrolments of both sexes of Portugal in 2005 to that in 2011?
Offer a very short reply. 0.92. What is the ratio of the Number of enrolments of both sexes of Togo in 2005 to that in 2011?
Make the answer very short. 0.74. What is the ratio of the Number of enrolments of both sexes of Latin America(developing only) in 2006 to that in 2007?
Offer a very short reply. 1. What is the ratio of the Number of enrolments of both sexes in Ghana in 2006 to that in 2007?
Ensure brevity in your answer.  0.9. What is the ratio of the Number of enrolments of both sexes in Portugal in 2006 to that in 2007?
Give a very brief answer. 0.97. What is the ratio of the Number of enrolments of both sexes in Togo in 2006 to that in 2007?
Your answer should be compact. 1.05. What is the ratio of the Number of enrolments of both sexes of Latin America(developing only) in 2006 to that in 2011?
Make the answer very short. 0.96. What is the ratio of the Number of enrolments of both sexes in Ghana in 2006 to that in 2011?
Your answer should be compact. 0.68. What is the ratio of the Number of enrolments of both sexes in Portugal in 2006 to that in 2011?
Your response must be concise. 0.91. What is the ratio of the Number of enrolments of both sexes of Togo in 2006 to that in 2011?
Ensure brevity in your answer.  0.79. What is the ratio of the Number of enrolments of both sexes of Latin America(developing only) in 2007 to that in 2011?
Your answer should be compact. 0.96. What is the ratio of the Number of enrolments of both sexes of Ghana in 2007 to that in 2011?
Your answer should be compact. 0.75. What is the ratio of the Number of enrolments of both sexes in Portugal in 2007 to that in 2011?
Make the answer very short. 0.94. What is the ratio of the Number of enrolments of both sexes in Togo in 2007 to that in 2011?
Offer a very short reply. 0.75. What is the difference between the highest and the second highest Number of enrolments of both sexes of Latin America(developing only)?
Your response must be concise. 1.90e+06. What is the difference between the highest and the second highest Number of enrolments of both sexes in Ghana?
Make the answer very short. 5.30e+05. What is the difference between the highest and the second highest Number of enrolments of both sexes in Portugal?
Make the answer very short. 1.61e+04. What is the difference between the highest and the second highest Number of enrolments of both sexes in Togo?
Provide a succinct answer. 1.16e+05. What is the difference between the highest and the lowest Number of enrolments of both sexes in Latin America(developing only)?
Your answer should be compact. 4.19e+06. What is the difference between the highest and the lowest Number of enrolments of both sexes of Ghana?
Your response must be concise. 1.12e+06. What is the difference between the highest and the lowest Number of enrolments of both sexes in Portugal?
Your response must be concise. 1.51e+05. What is the difference between the highest and the lowest Number of enrolments of both sexes in Togo?
Keep it short and to the point. 2.58e+05. 